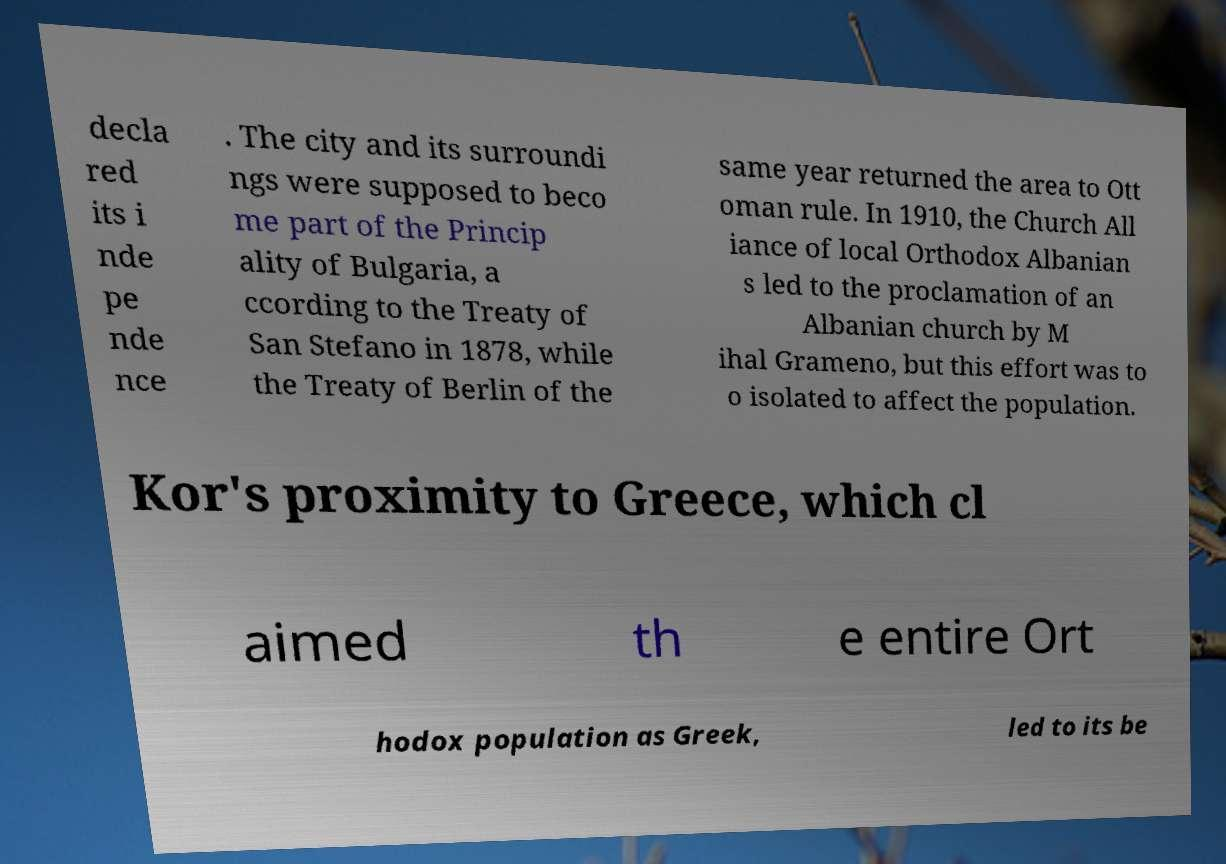There's text embedded in this image that I need extracted. Can you transcribe it verbatim? decla red its i nde pe nde nce . The city and its surroundi ngs were supposed to beco me part of the Princip ality of Bulgaria, a ccording to the Treaty of San Stefano in 1878, while the Treaty of Berlin of the same year returned the area to Ott oman rule. In 1910, the Church All iance of local Orthodox Albanian s led to the proclamation of an Albanian church by M ihal Grameno, but this effort was to o isolated to affect the population. Kor's proximity to Greece, which cl aimed th e entire Ort hodox population as Greek, led to its be 